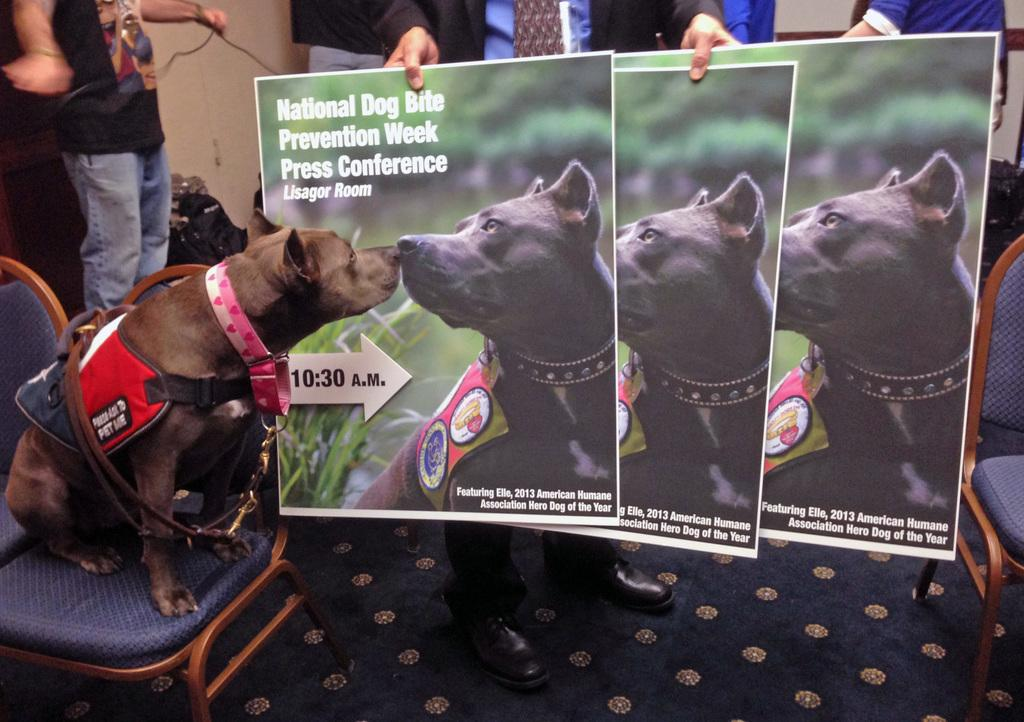What can be seen hanging on the walls in the image? There are posters in the image. What is the dog doing in the image? The dog is sitting on a chair in the image. Are there any people present in the image? Yes, there are people standing in the image. What type of ornament is hanging from the roof in the image? There is no ornament hanging from the roof in the image, as there is no mention of a roof in the provided facts. How does the drain affect the people standing in the image? There is no mention of a drain in the provided facts, so it cannot be determined how it might affect the people in the image. 